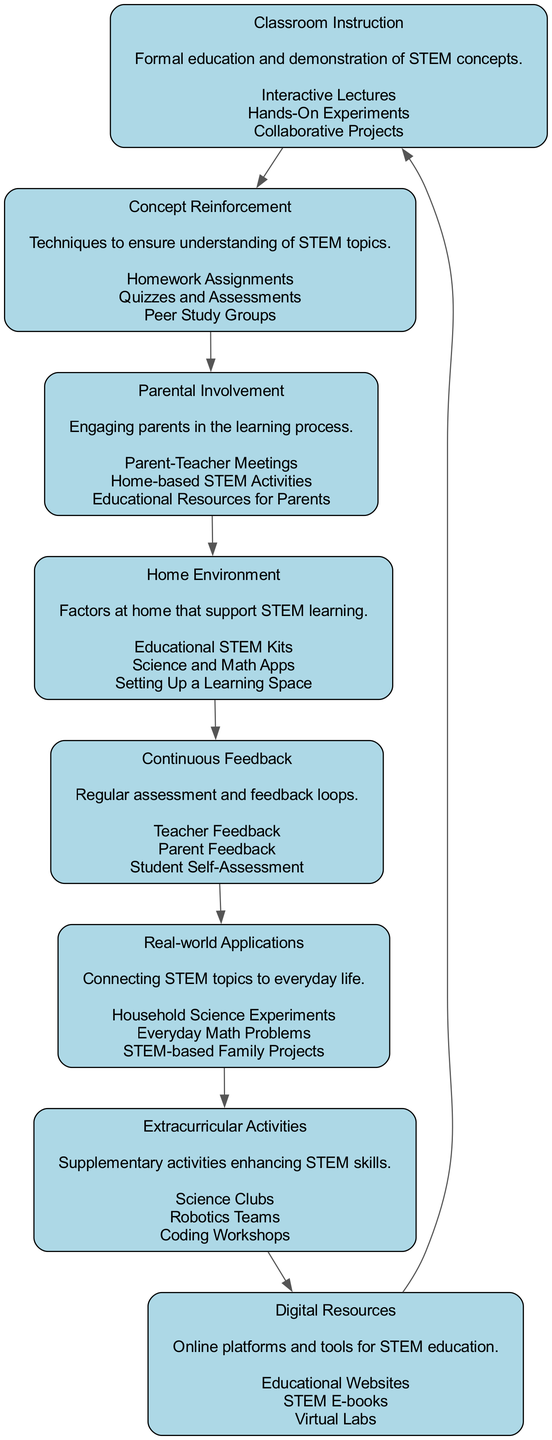What is the first block in the diagram? The first block, as indicated at the top of the flowchart, is "Classroom Instruction," where formal education and demonstration of STEM concepts occur.
Answer: Classroom Instruction How many key components are listed for "Parental Involvement"? The "Parental Involvement" block lists three key components: Parent-Teacher Meetings, Home-based STEM Activities, and Educational Resources for Parents.
Answer: Three Which block follows "Home Environment"? The flowchart connects "Home Environment" directly to "Continuous Feedback," indicating that it is the next block in the sequence.
Answer: Continuous Feedback What type of activities are included in "Extracurricular Activities"? The "Extracurricular Activities" block mentions Science Clubs, Robotics Teams, and Coding Workshops as the types of activities that enhance STEM skills.
Answer: Science Clubs, Robotics Teams, Coding Workshops What connects "Real-world Applications" to the previous block? The flow of the diagram shows an edge from "Continuous Feedback" to "Real-world Applications," indicating that the latter follows the former directly, emphasizing the step-wise connection.
Answer: Continuous Feedback What is the role of the "Digital Resources" block? "Digital Resources" acts as a resource nexus that links to "Classroom Instruction" and includes tools like Educational Websites and Virtual Labs, acting as support for both classroom and home environments in STEM learning.
Answer: Support for learning What is the overall purpose of "Continuous Feedback"? "Continuous Feedback" serves as a regular assessment and feedback loop that incorporates teacher and parent feedback along with student self-assessment to ensure the effectiveness of STEM education.
Answer: Regular assessment Which element provides techniques to enhance understanding of STEM topics? "Concept Reinforcement" emphasizes various techniques such as Homework Assignments and Peer Study Groups, which ensure that students grasp STEM topics effectively through ongoing engagement in their learning process.
Answer: Concept Reinforcement What is the last block connected back to the first block? The last block, "Digital Resources," connects back to "Classroom Instruction," completing the flow of the diagram and showing how online tools return to support classroom learning.
Answer: Digital Resources 